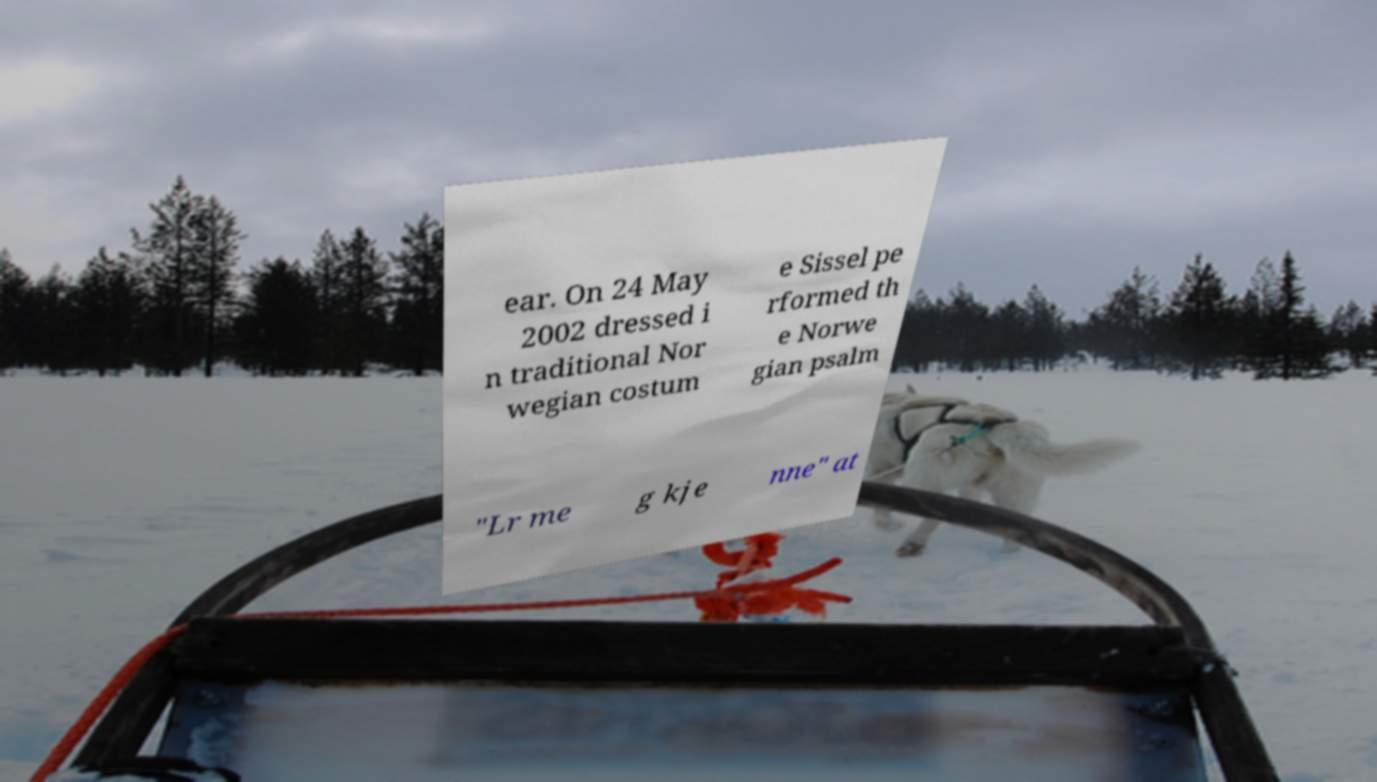There's text embedded in this image that I need extracted. Can you transcribe it verbatim? ear. On 24 May 2002 dressed i n traditional Nor wegian costum e Sissel pe rformed th e Norwe gian psalm "Lr me g kje nne" at 